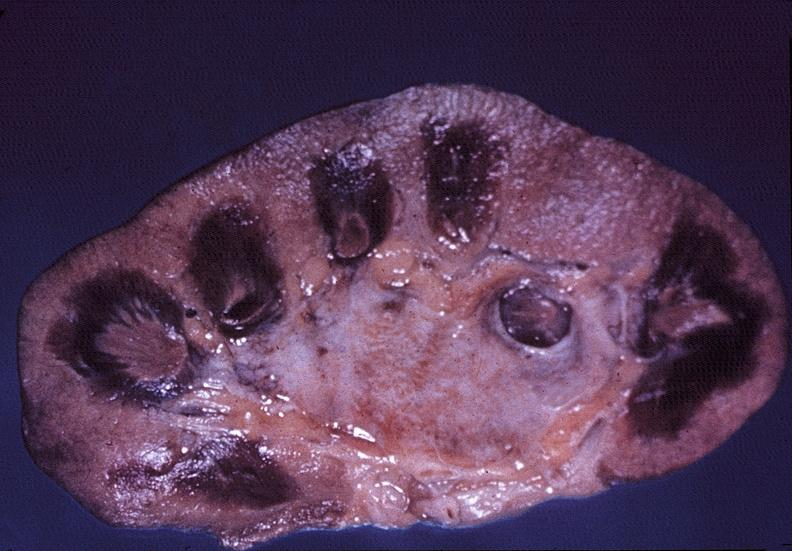where is this?
Answer the question using a single word or phrase. Urinary 